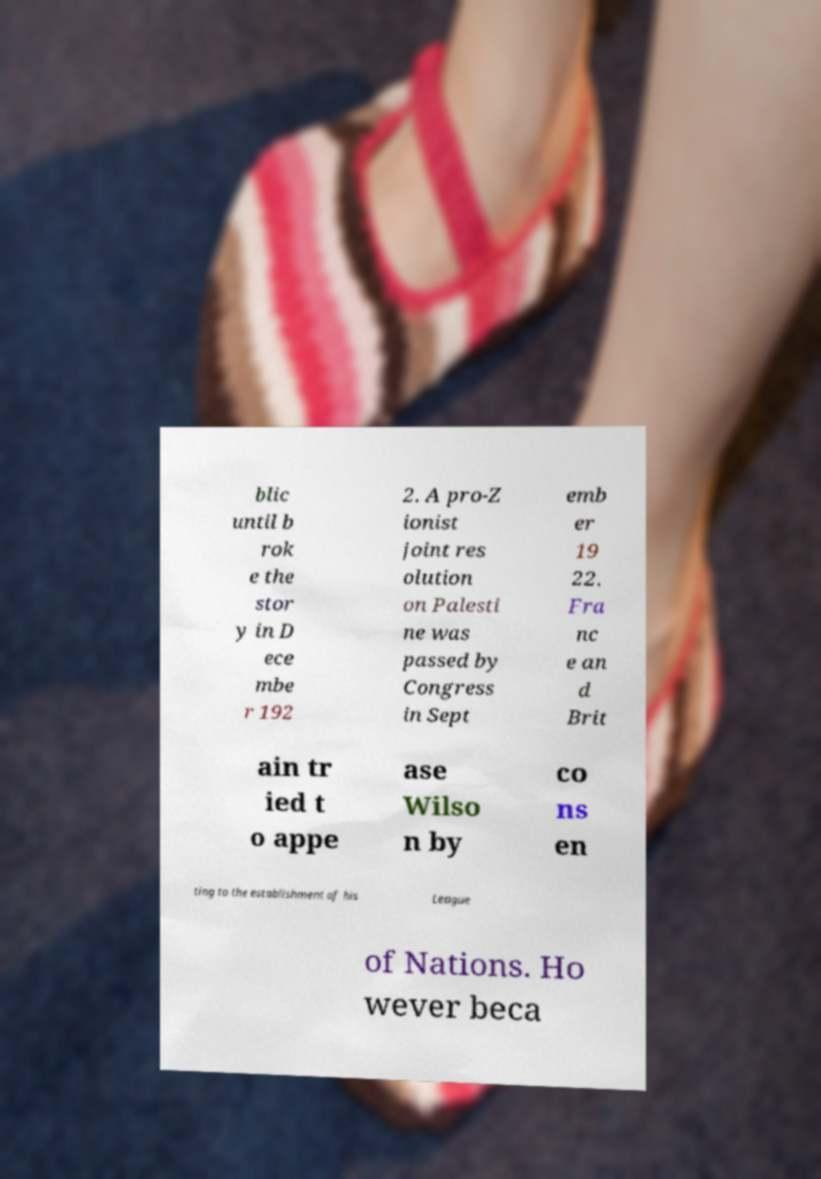Please identify and transcribe the text found in this image. blic until b rok e the stor y in D ece mbe r 192 2. A pro-Z ionist joint res olution on Palesti ne was passed by Congress in Sept emb er 19 22. Fra nc e an d Brit ain tr ied t o appe ase Wilso n by co ns en ting to the establishment of his League of Nations. Ho wever beca 